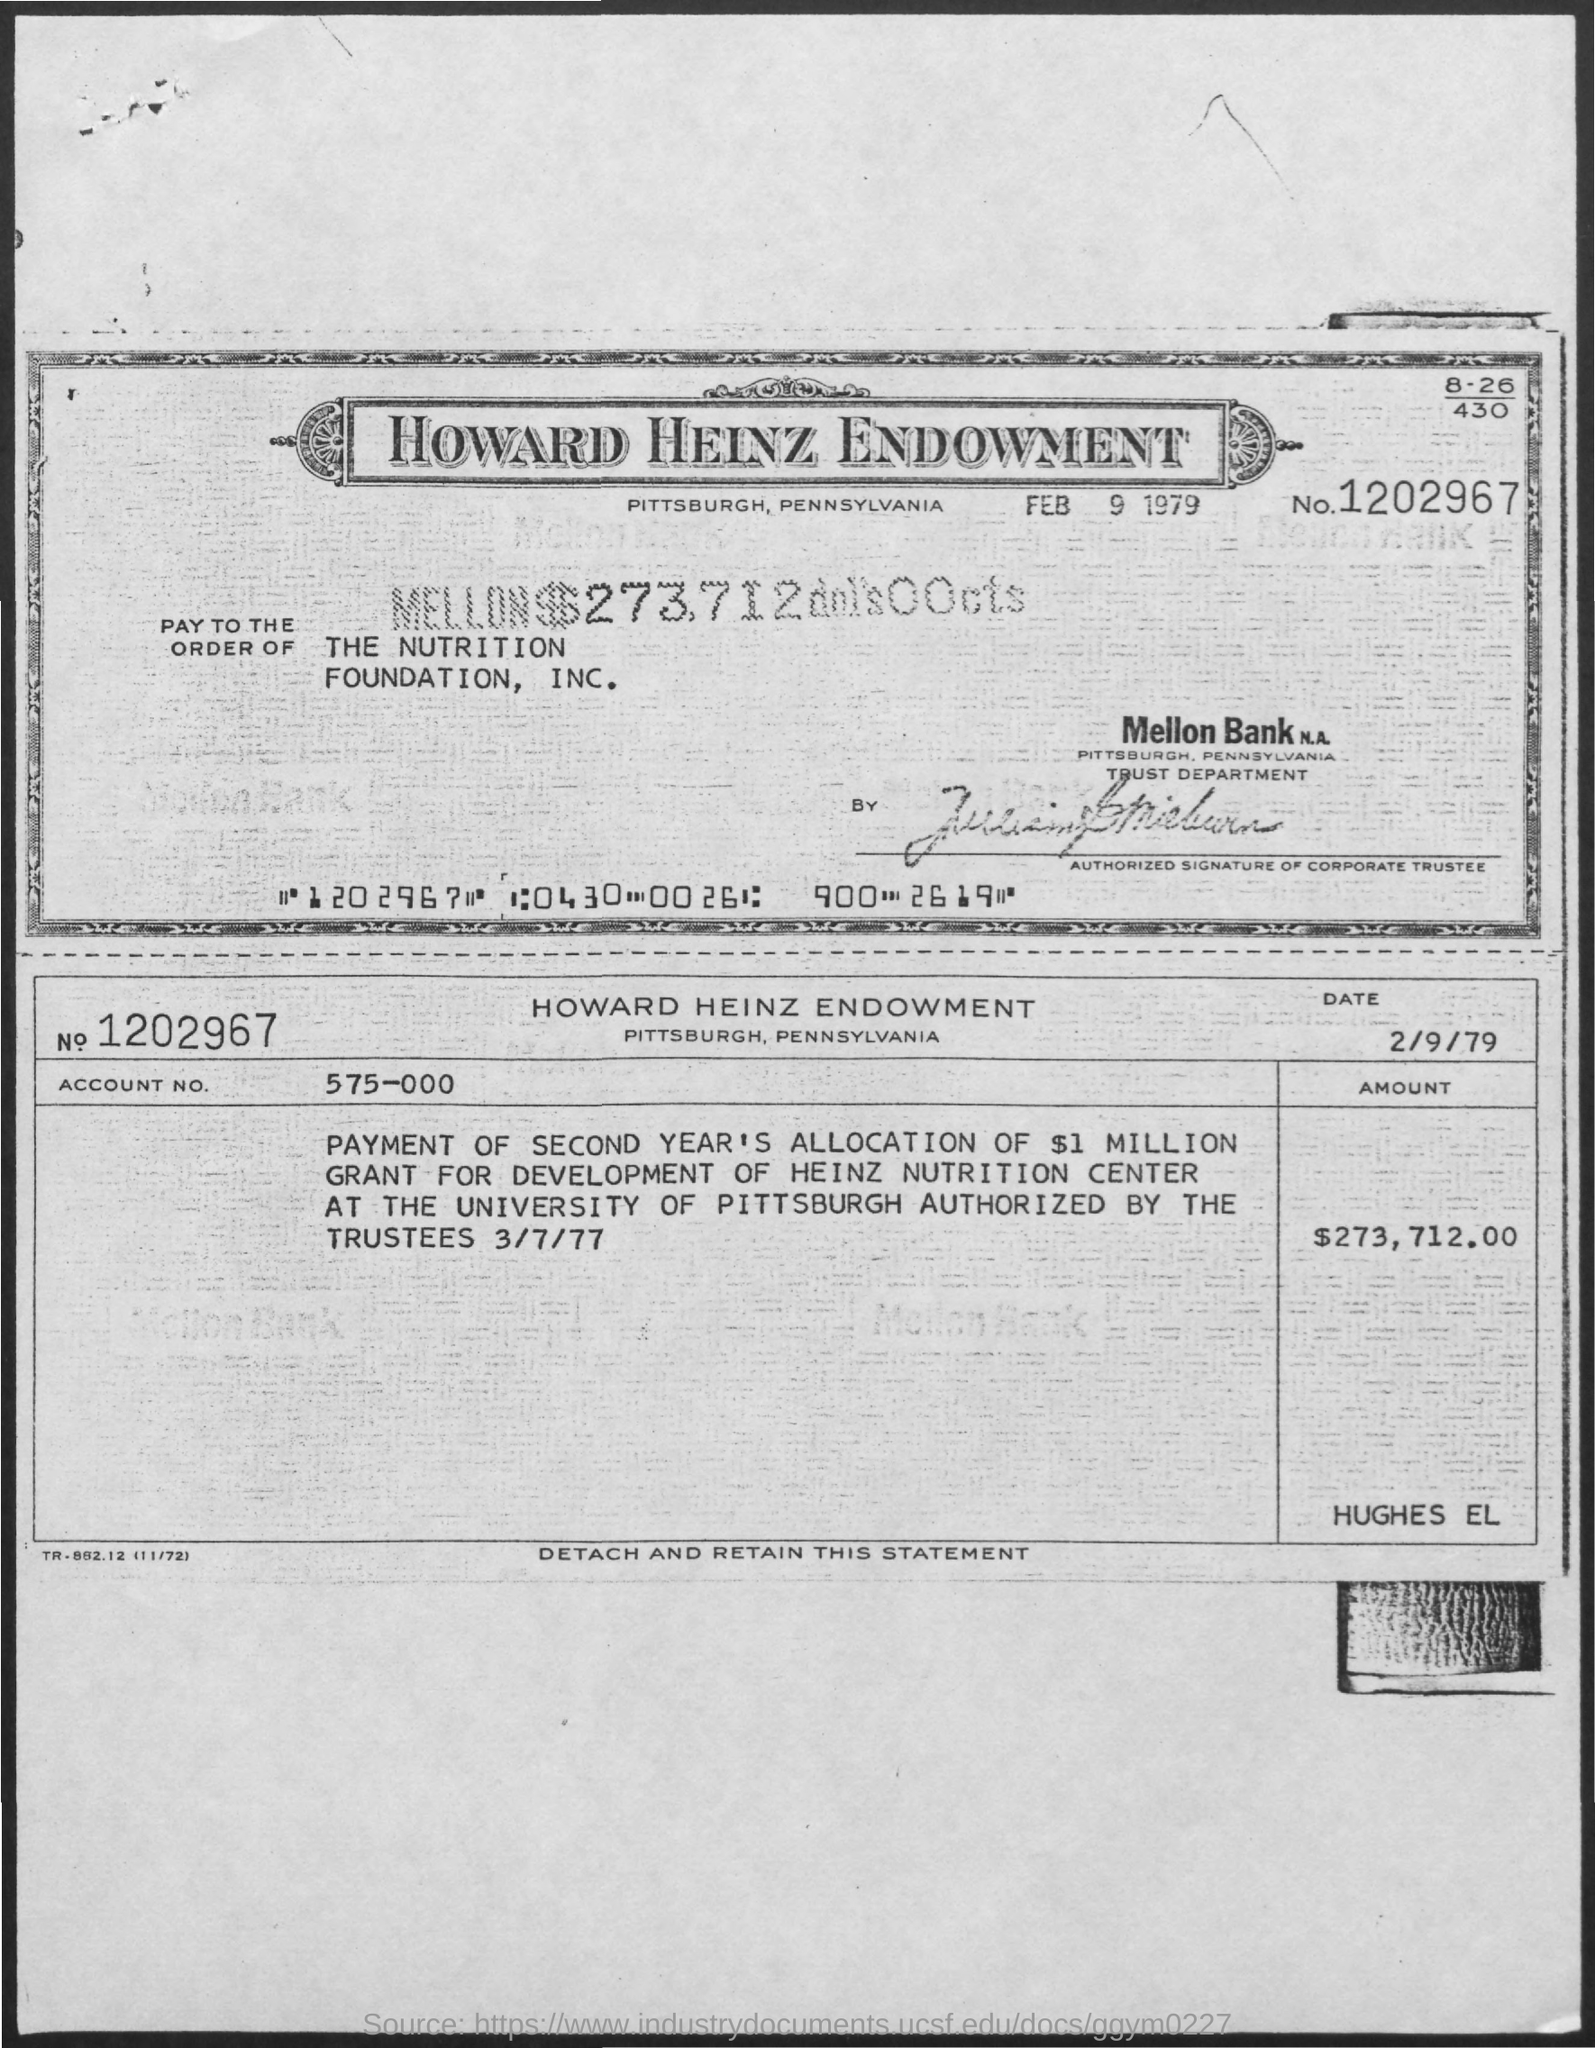What is the account no. mentioned ?
Provide a succinct answer. 575-000. What is the amount mentioned ?
Offer a terse response. $ 273,712.00. What is the no. mentioned in the given form ?
Provide a succinct answer. 1202967. What is the date mentioned on the 1st copy ?
Keep it short and to the point. FEB 9 1979. What is the date mentioned in the 2nd copy ?
Keep it short and to the point. 2/9/79. What is the name mentioned at pay to the order of ?
Offer a very short reply. THE NUTRITION FOUNDATION INC. 